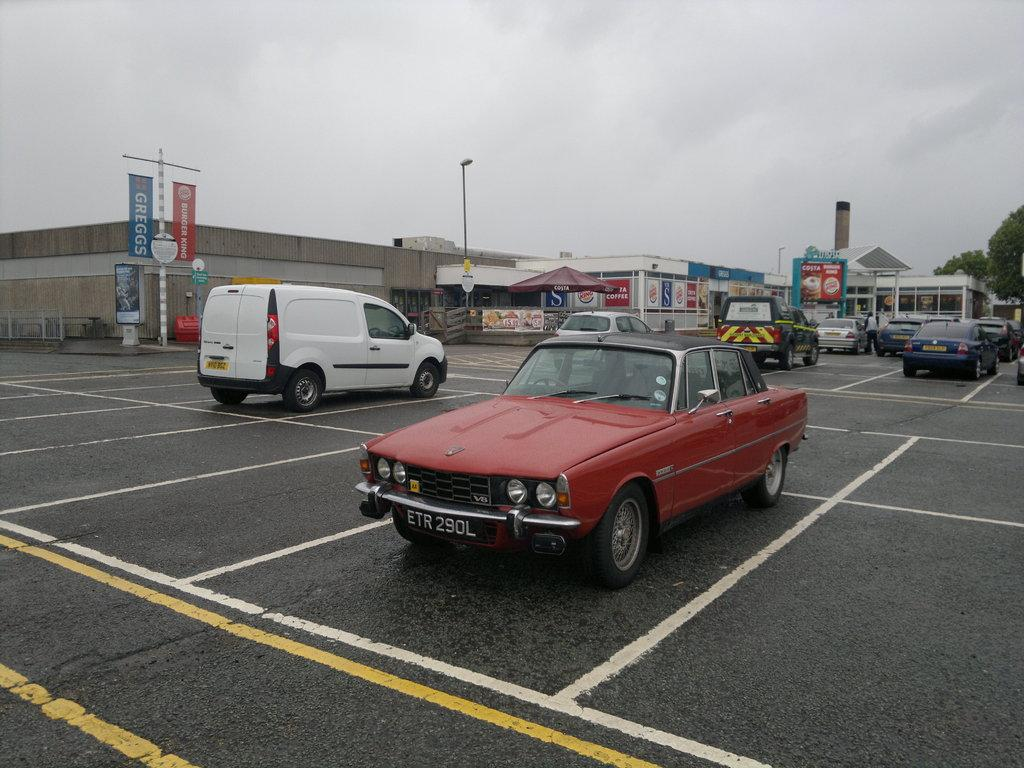What is the main feature of the image? There is a road in the image. What is happening on the road? Vehicles are parked on the road. What can be seen in the background of the image? There are hoardings, buildings, trees, and poles visible in the background of the image. What is the condition of the sky in the image? Clouds are visible in the sky. Can you tell me how many frogs are hopping on the road in the image? There are no frogs present in the image; it features a road with parked vehicles. What type of station is visible in the background of the image? There is no station visible in the background of the image. 